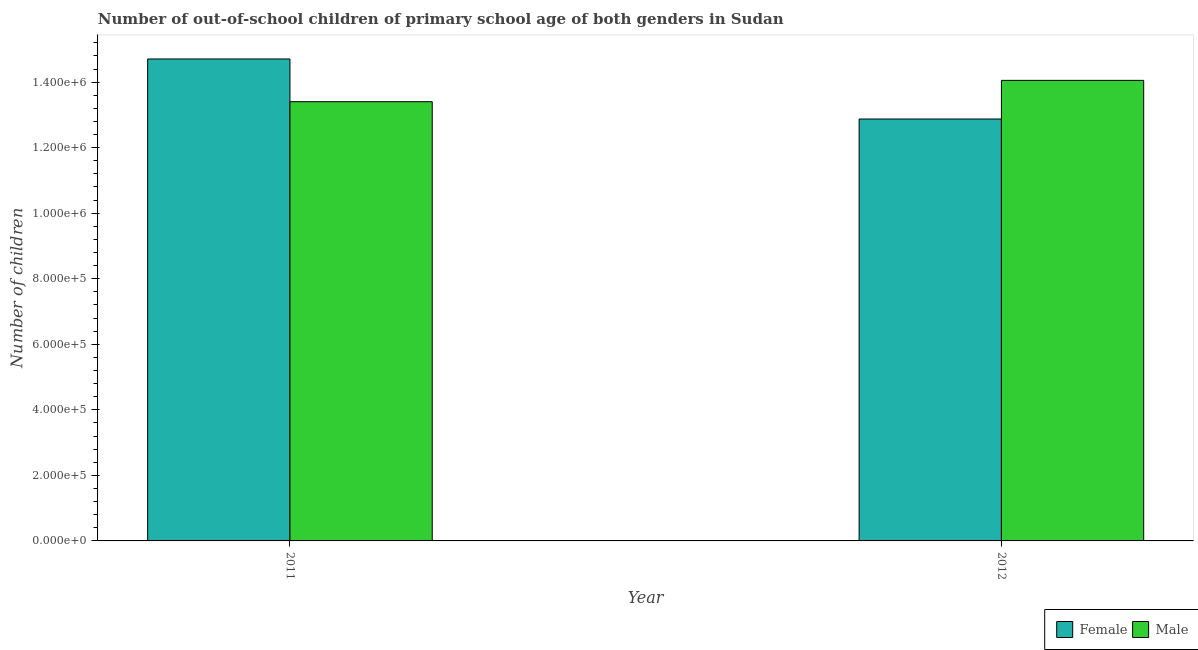How many groups of bars are there?
Keep it short and to the point. 2. Are the number of bars per tick equal to the number of legend labels?
Provide a succinct answer. Yes. How many bars are there on the 2nd tick from the left?
Provide a short and direct response. 2. In how many cases, is the number of bars for a given year not equal to the number of legend labels?
Ensure brevity in your answer.  0. What is the number of male out-of-school students in 2012?
Make the answer very short. 1.41e+06. Across all years, what is the maximum number of female out-of-school students?
Offer a terse response. 1.47e+06. Across all years, what is the minimum number of male out-of-school students?
Your answer should be compact. 1.34e+06. What is the total number of male out-of-school students in the graph?
Keep it short and to the point. 2.75e+06. What is the difference between the number of male out-of-school students in 2011 and that in 2012?
Your answer should be compact. -6.51e+04. What is the difference between the number of female out-of-school students in 2012 and the number of male out-of-school students in 2011?
Give a very brief answer. -1.83e+05. What is the average number of male out-of-school students per year?
Provide a succinct answer. 1.37e+06. What is the ratio of the number of female out-of-school students in 2011 to that in 2012?
Make the answer very short. 1.14. What does the 1st bar from the right in 2011 represents?
Ensure brevity in your answer.  Male. How many bars are there?
Offer a terse response. 4. How many years are there in the graph?
Offer a very short reply. 2. What is the difference between two consecutive major ticks on the Y-axis?
Your response must be concise. 2.00e+05. Are the values on the major ticks of Y-axis written in scientific E-notation?
Provide a short and direct response. Yes. Where does the legend appear in the graph?
Provide a short and direct response. Bottom right. What is the title of the graph?
Provide a succinct answer. Number of out-of-school children of primary school age of both genders in Sudan. Does "Researchers" appear as one of the legend labels in the graph?
Offer a terse response. No. What is the label or title of the Y-axis?
Make the answer very short. Number of children. What is the Number of children in Female in 2011?
Ensure brevity in your answer.  1.47e+06. What is the Number of children in Male in 2011?
Provide a short and direct response. 1.34e+06. What is the Number of children of Female in 2012?
Your response must be concise. 1.29e+06. What is the Number of children of Male in 2012?
Keep it short and to the point. 1.41e+06. Across all years, what is the maximum Number of children of Female?
Keep it short and to the point. 1.47e+06. Across all years, what is the maximum Number of children in Male?
Keep it short and to the point. 1.41e+06. Across all years, what is the minimum Number of children of Female?
Your response must be concise. 1.29e+06. Across all years, what is the minimum Number of children in Male?
Offer a terse response. 1.34e+06. What is the total Number of children of Female in the graph?
Your answer should be very brief. 2.76e+06. What is the total Number of children in Male in the graph?
Keep it short and to the point. 2.75e+06. What is the difference between the Number of children in Female in 2011 and that in 2012?
Give a very brief answer. 1.83e+05. What is the difference between the Number of children in Male in 2011 and that in 2012?
Provide a succinct answer. -6.51e+04. What is the difference between the Number of children of Female in 2011 and the Number of children of Male in 2012?
Offer a terse response. 6.53e+04. What is the average Number of children in Female per year?
Your response must be concise. 1.38e+06. What is the average Number of children in Male per year?
Make the answer very short. 1.37e+06. In the year 2011, what is the difference between the Number of children in Female and Number of children in Male?
Your answer should be compact. 1.30e+05. In the year 2012, what is the difference between the Number of children of Female and Number of children of Male?
Provide a short and direct response. -1.18e+05. What is the ratio of the Number of children in Female in 2011 to that in 2012?
Give a very brief answer. 1.14. What is the ratio of the Number of children in Male in 2011 to that in 2012?
Make the answer very short. 0.95. What is the difference between the highest and the second highest Number of children of Female?
Make the answer very short. 1.83e+05. What is the difference between the highest and the second highest Number of children in Male?
Offer a very short reply. 6.51e+04. What is the difference between the highest and the lowest Number of children of Female?
Give a very brief answer. 1.83e+05. What is the difference between the highest and the lowest Number of children of Male?
Provide a short and direct response. 6.51e+04. 